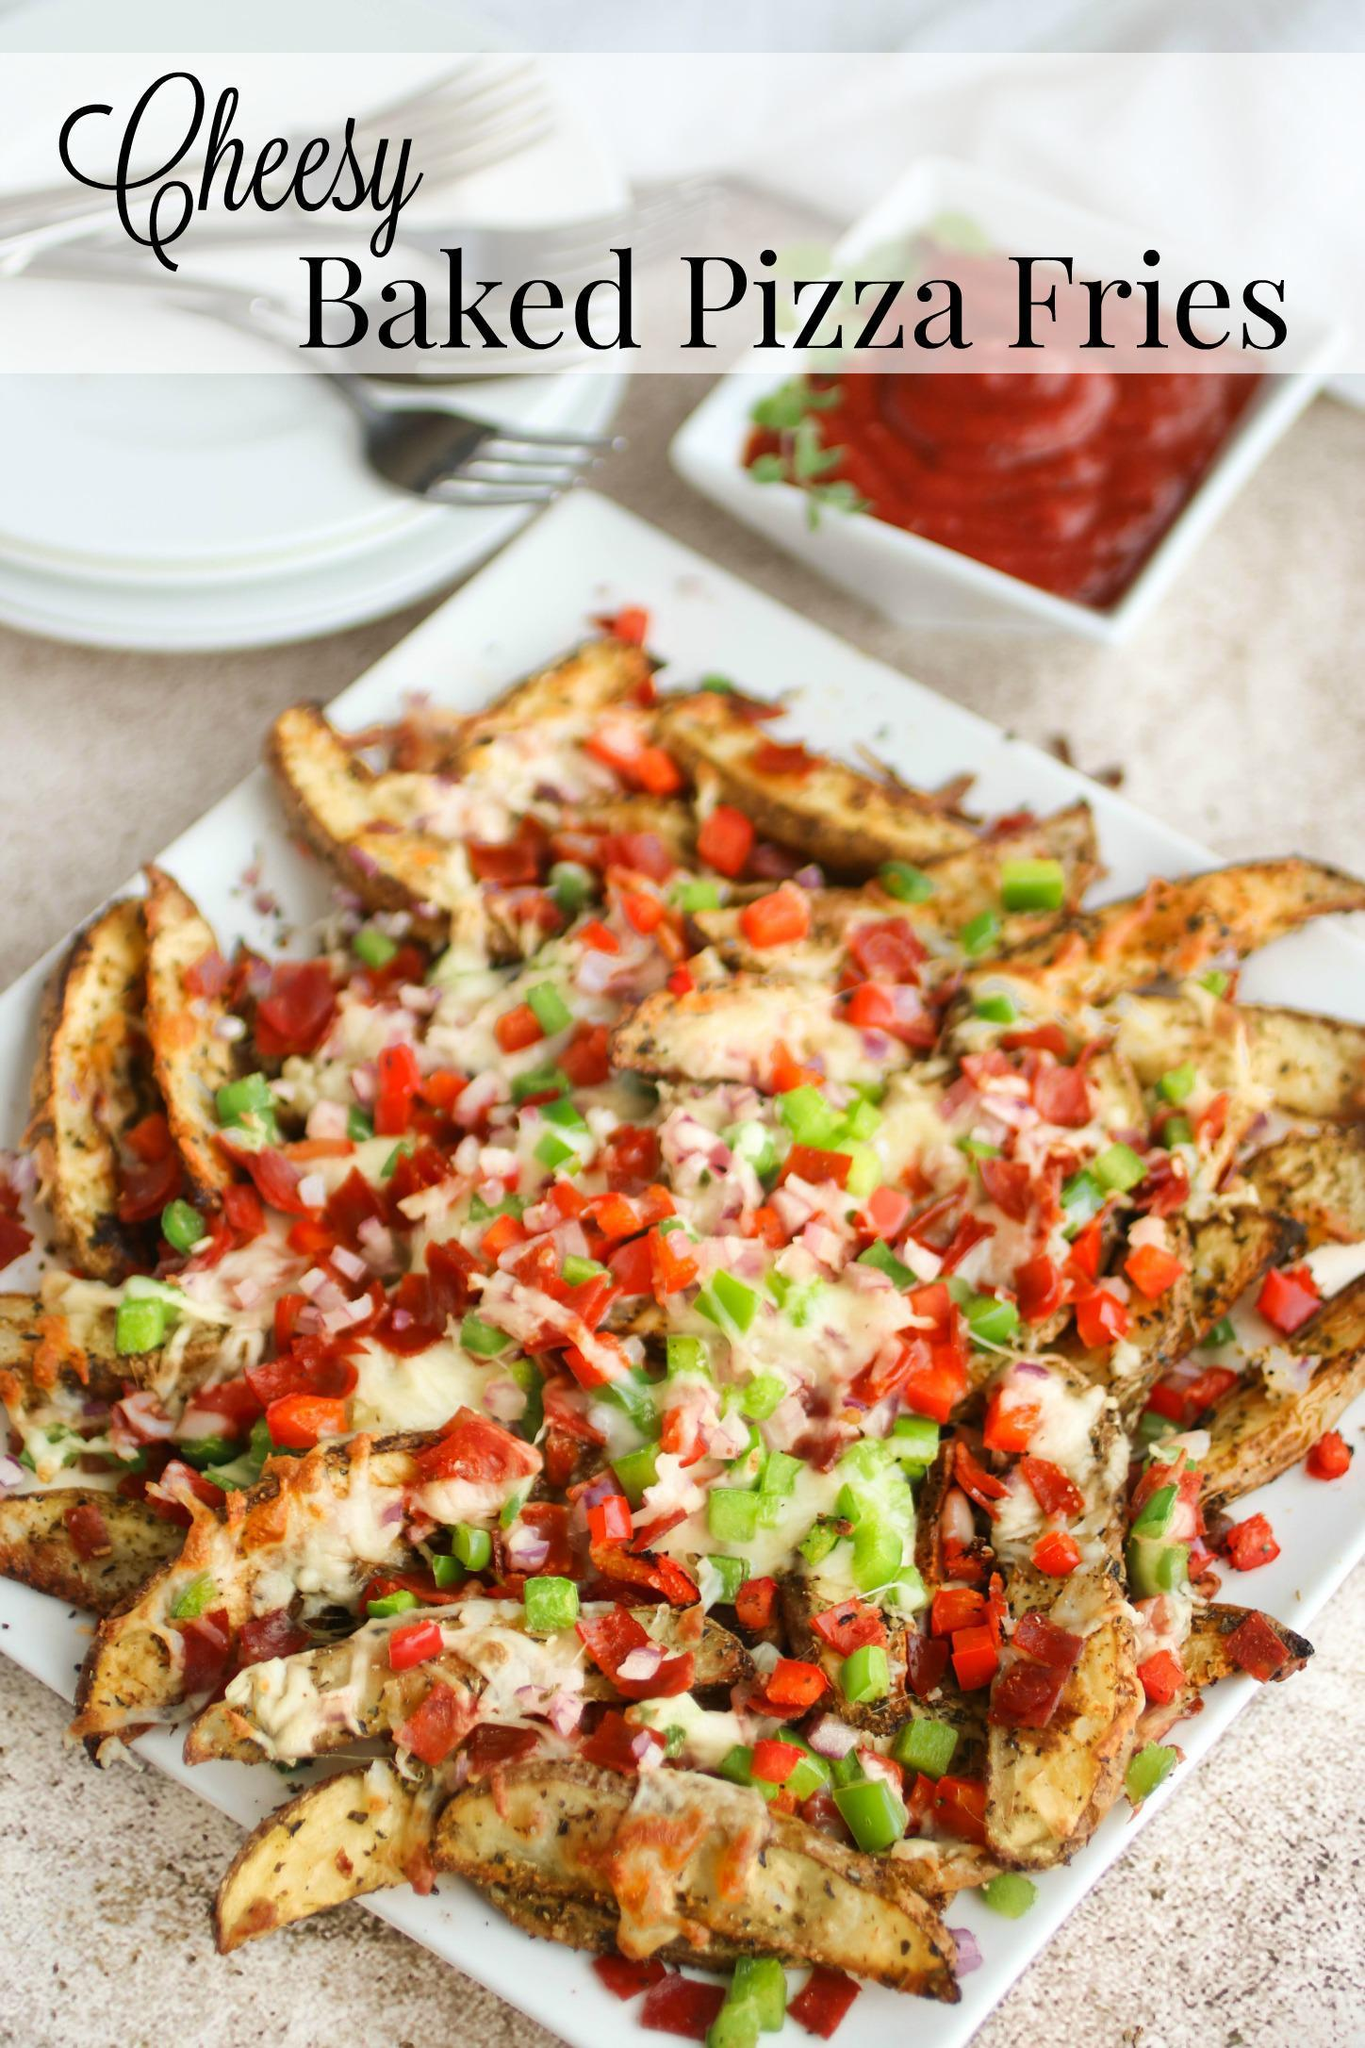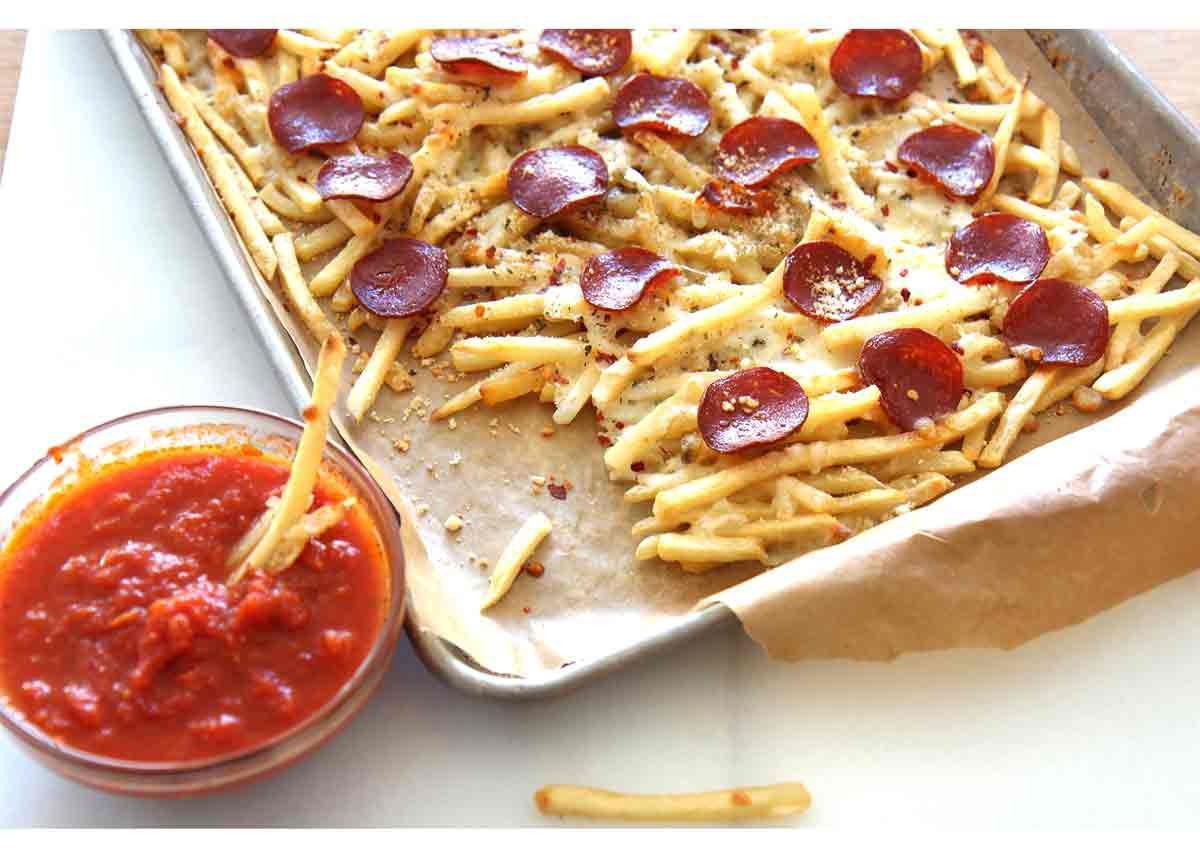The first image is the image on the left, the second image is the image on the right. Examine the images to the left and right. Is the description "The right image contains one order of pizza fries and one ramekin of marinara." accurate? Answer yes or no. Yes. The first image is the image on the left, the second image is the image on the right. For the images shown, is this caption "The left image shows a round bowl of red-orange sauce next to but not touching a rectangular pan containing french fries with pepperonis on top." true? Answer yes or no. No. 